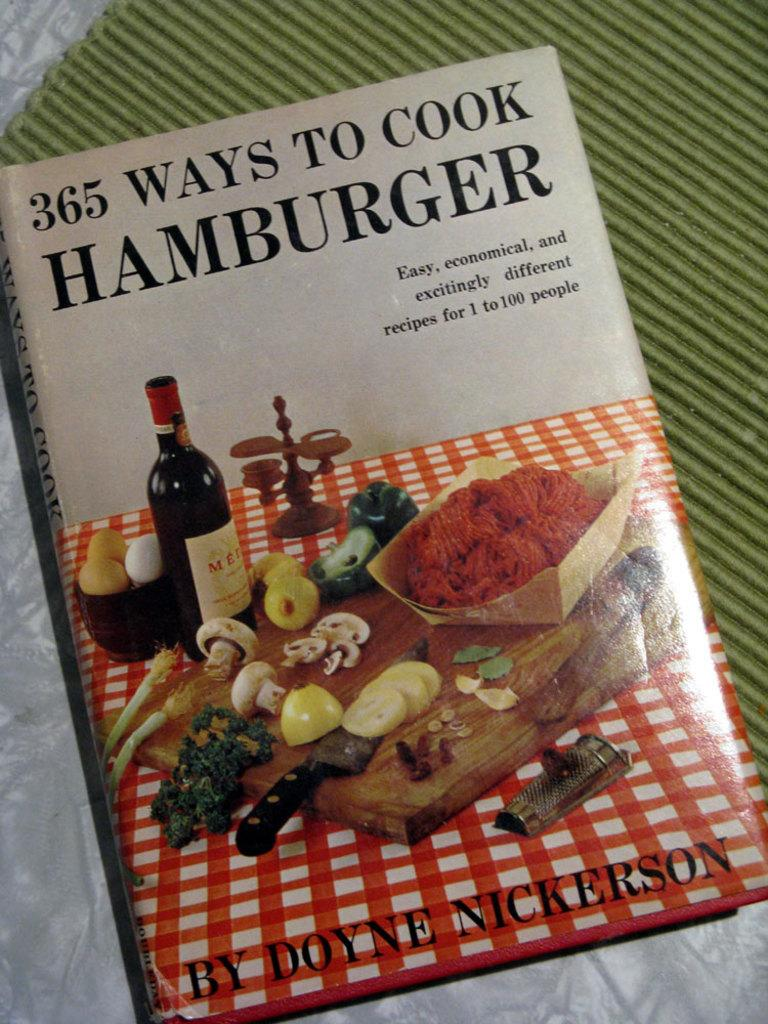<image>
Summarize the visual content of the image. A copy of 365 Ways To Cook Hamburger by Doyne Nickerson. 